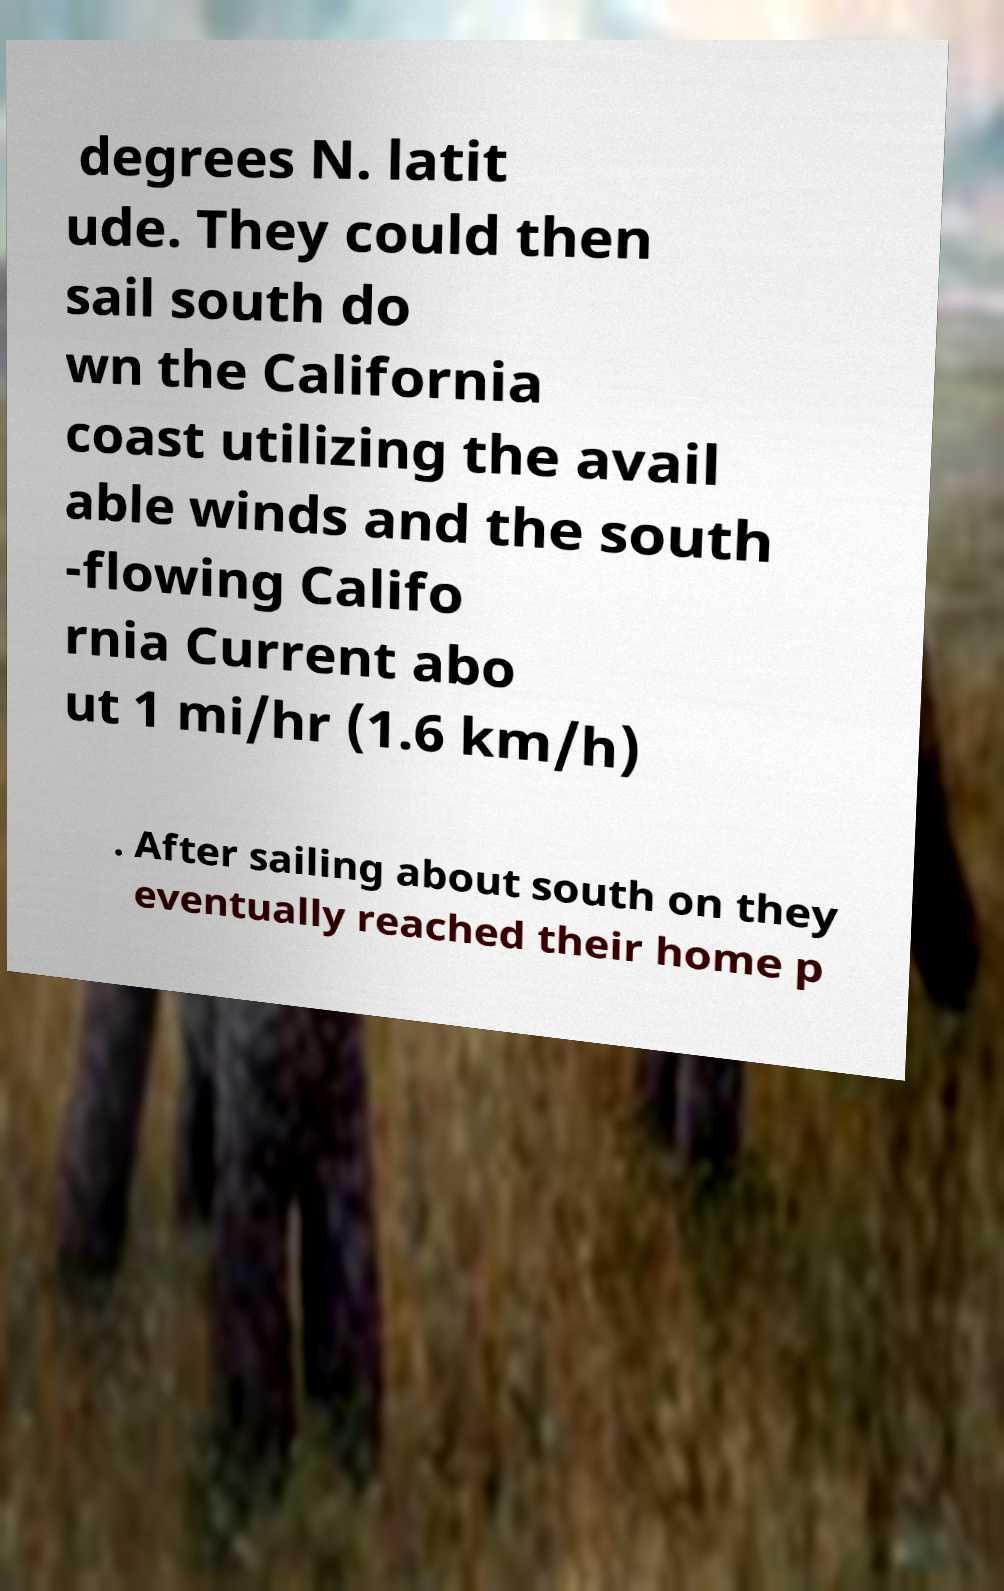I need the written content from this picture converted into text. Can you do that? degrees N. latit ude. They could then sail south do wn the California coast utilizing the avail able winds and the south -flowing Califo rnia Current abo ut 1 mi/hr (1.6 km/h) . After sailing about south on they eventually reached their home p 